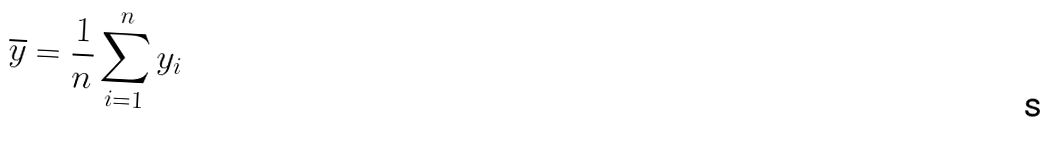Convert formula to latex. <formula><loc_0><loc_0><loc_500><loc_500>\overline { y } = \frac { 1 } { n } \sum _ { i = 1 } ^ { n } y _ { i }</formula> 